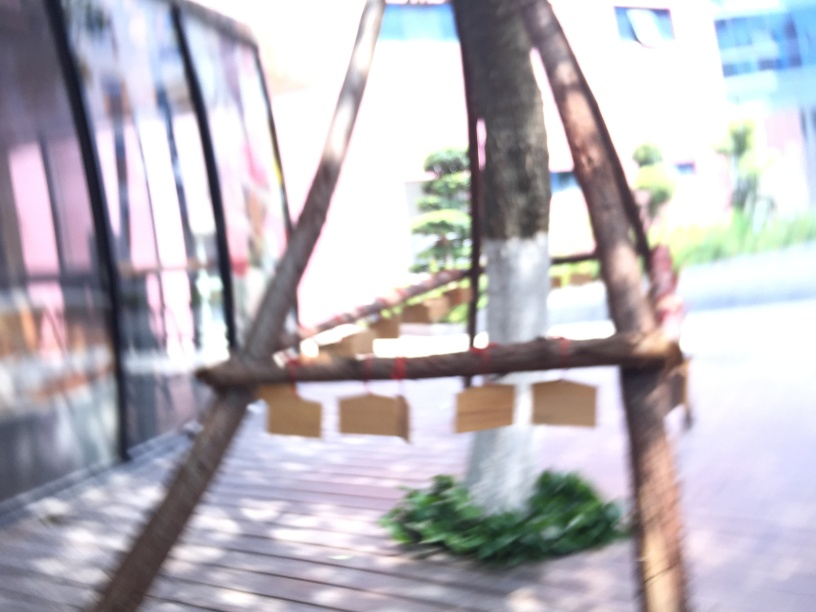How does the overexposure affect the image?
A. dark and sharp appearance
B. vibrant and clear appearance
C. colorful and balanced appearance
D. bright and hazy appearance
Answer with the option's letter from the given choices directly. The correct answer is D, 'bright and hazy appearance.' Overexposure in photography leads to increased brightness and a reduction in contrast, making the image appear washed out and details less distinct, which is evident in the provided image. 